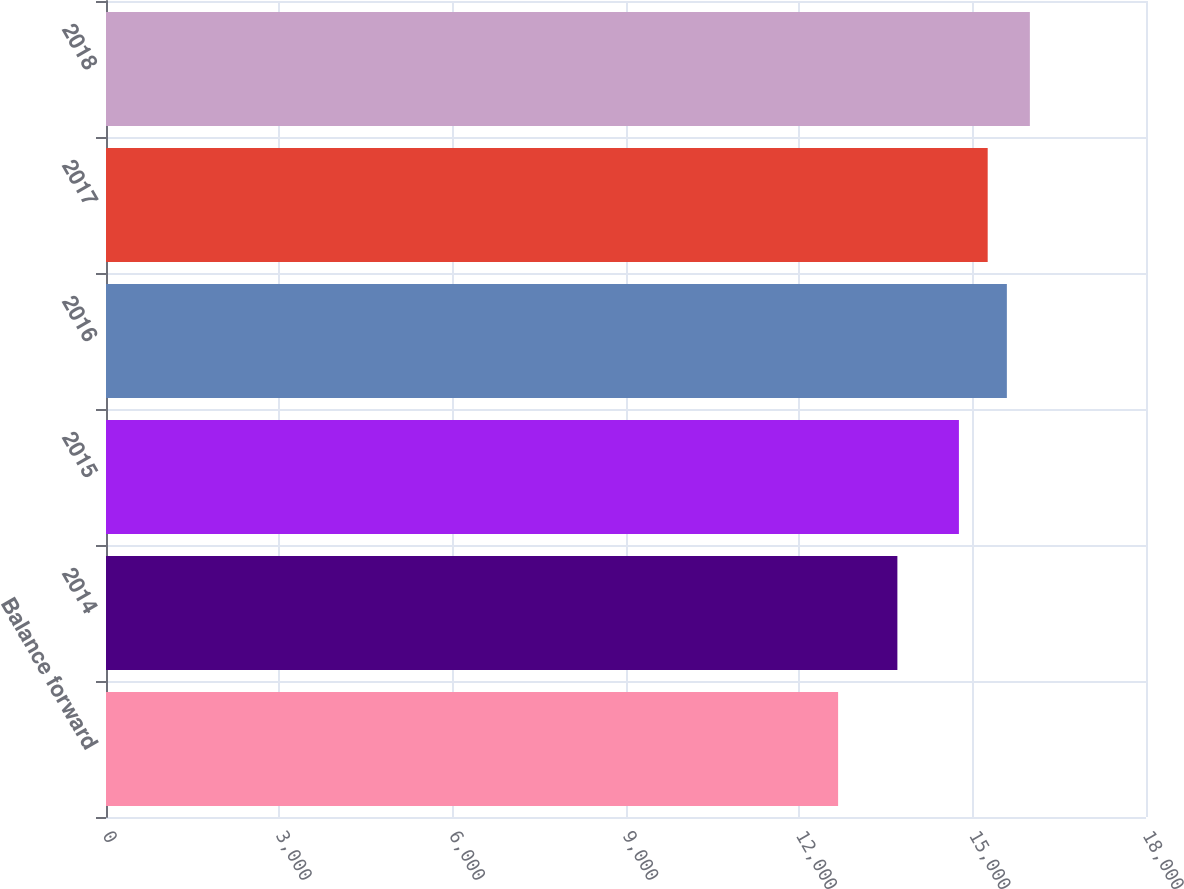Convert chart. <chart><loc_0><loc_0><loc_500><loc_500><bar_chart><fcel>Balance forward<fcel>2014<fcel>2015<fcel>2016<fcel>2017<fcel>2018<nl><fcel>12671<fcel>13697<fcel>14762<fcel>15591.9<fcel>15260<fcel>15990<nl></chart> 